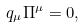<formula> <loc_0><loc_0><loc_500><loc_500>q _ { \mu } \Pi ^ { \mu } = 0 ,</formula> 